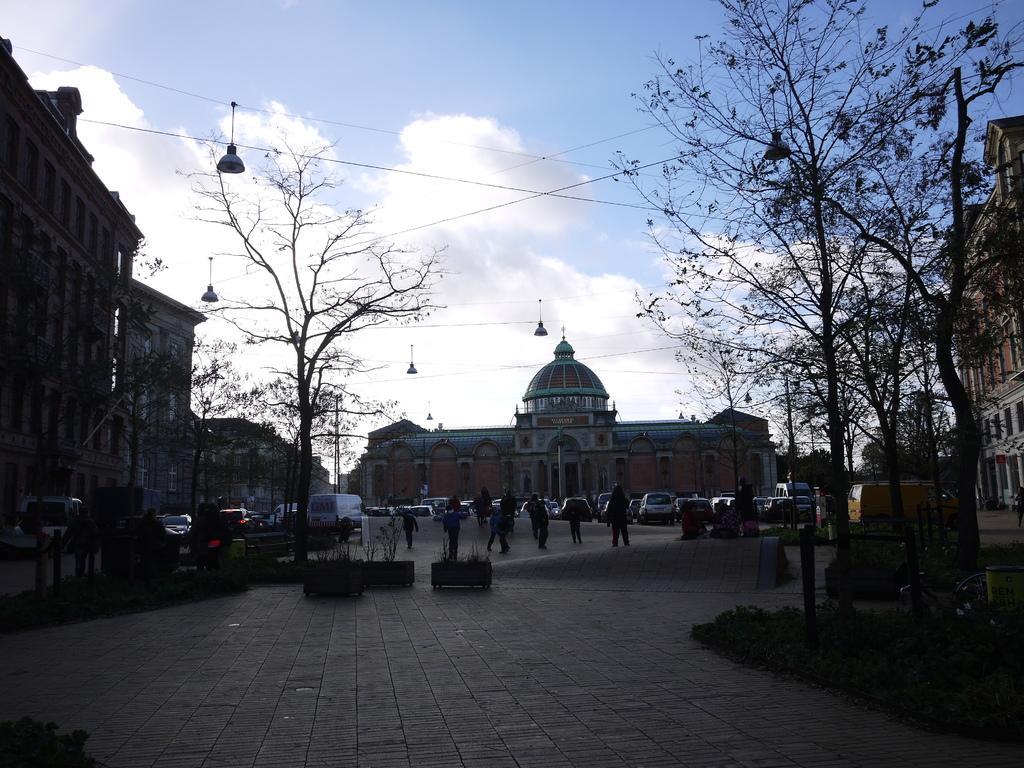Could you give a brief overview of what you see in this image? In this picture we can see a group of people, vehicles on the road, here we can see trees, buildings, electric poles and some objects and we can see sky in the background. 